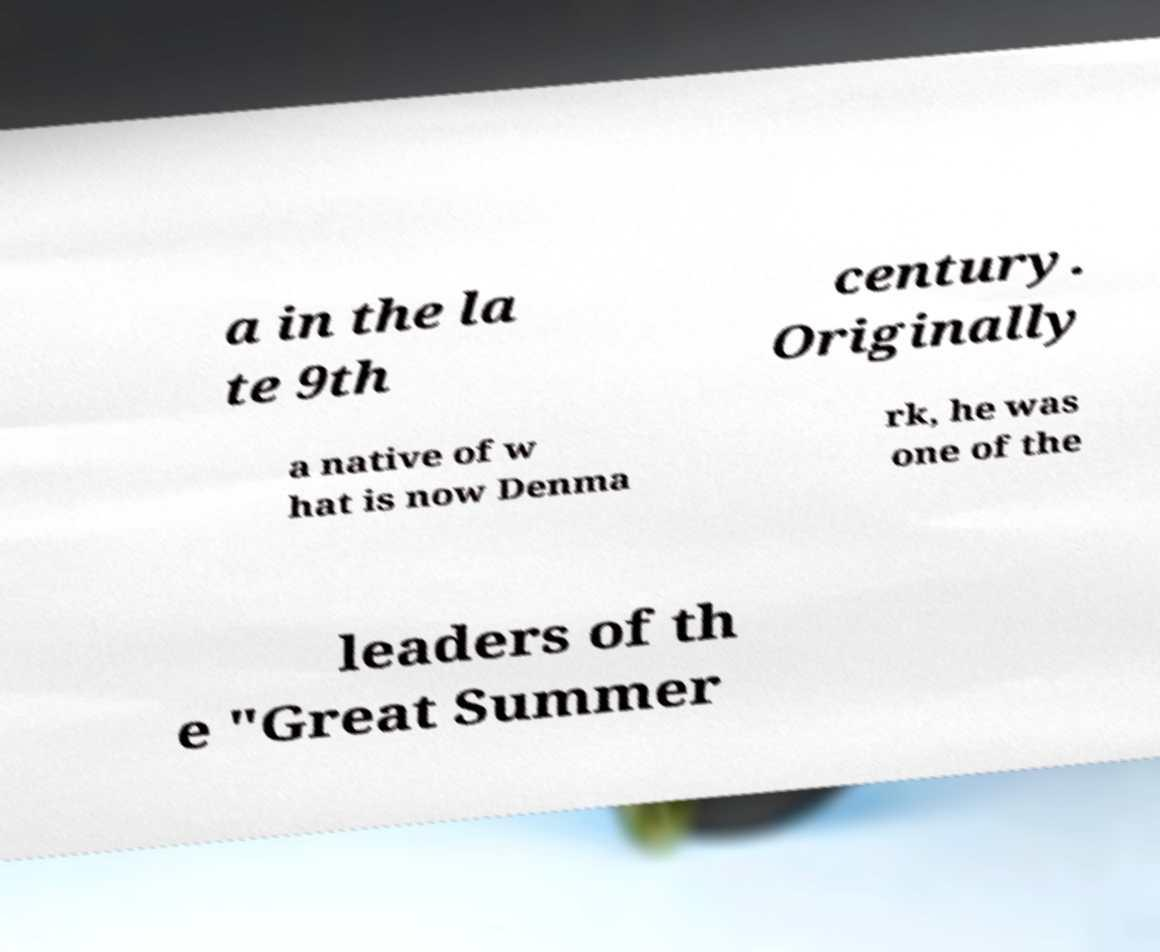What messages or text are displayed in this image? I need them in a readable, typed format. a in the la te 9th century. Originally a native of w hat is now Denma rk, he was one of the leaders of th e "Great Summer 